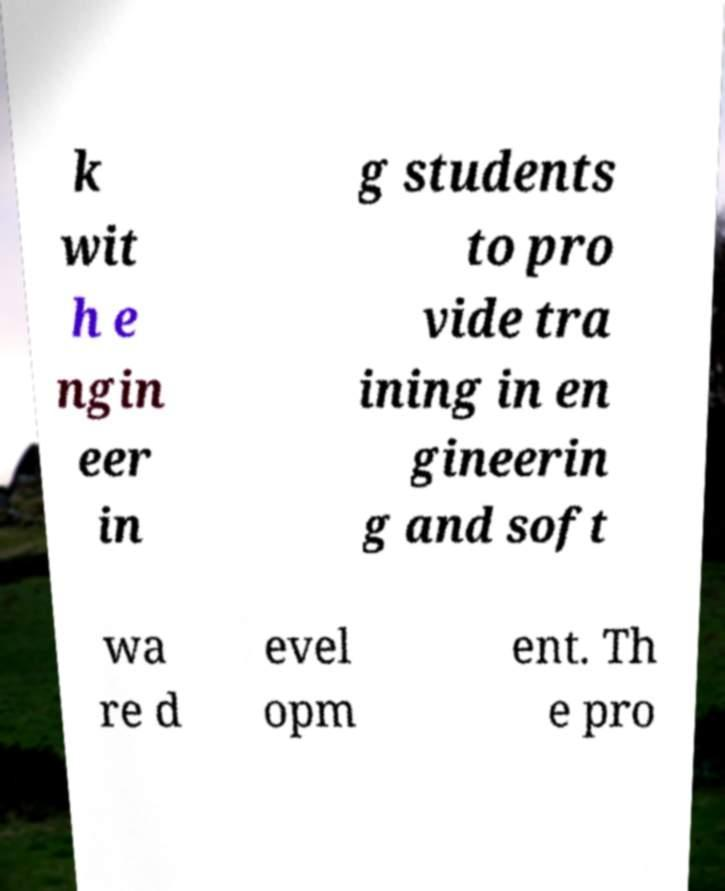Please read and relay the text visible in this image. What does it say? k wit h e ngin eer in g students to pro vide tra ining in en gineerin g and soft wa re d evel opm ent. Th e pro 